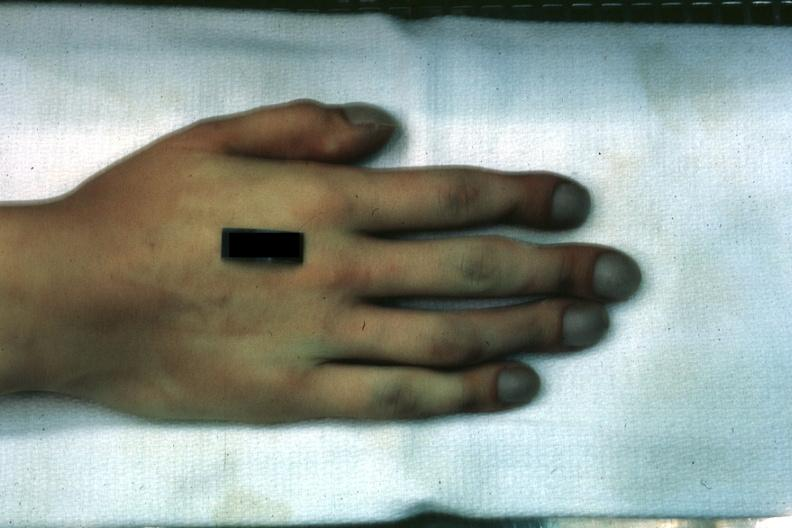what is present?
Answer the question using a single word or phrase. Hand 